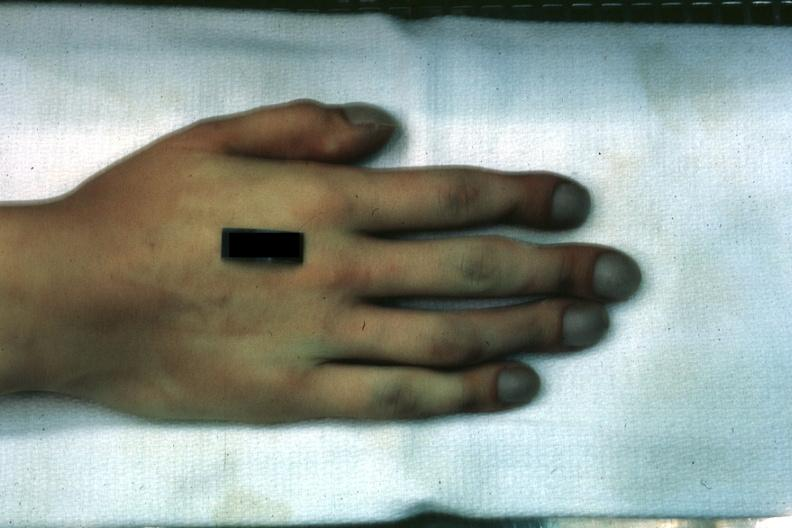what is present?
Answer the question using a single word or phrase. Hand 